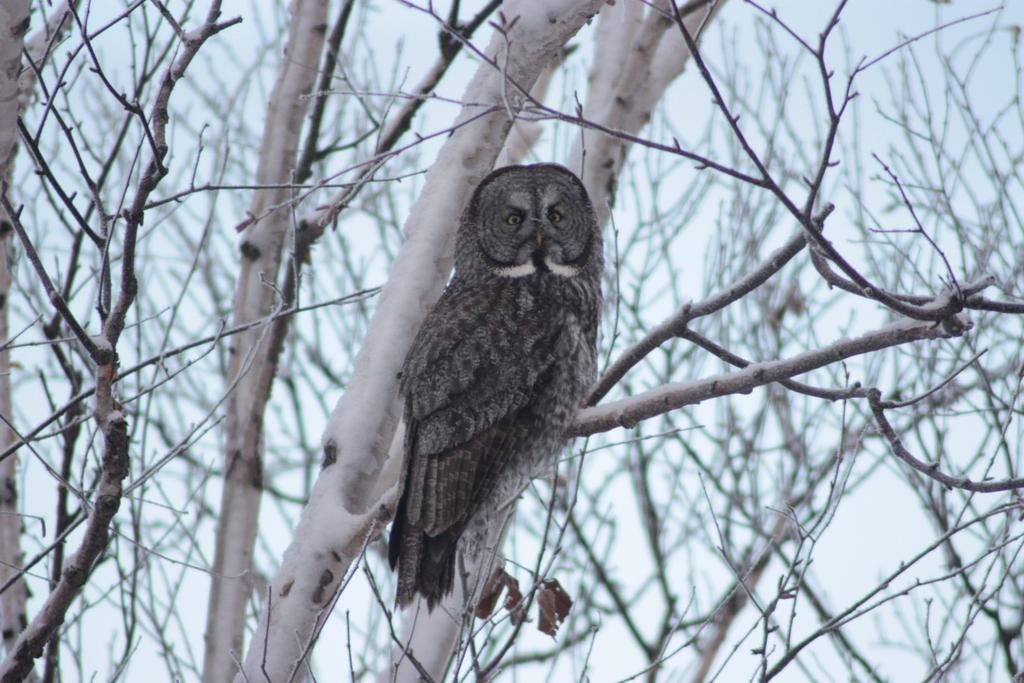What animal is the main subject of the image? There is an owl in the image. Where is the owl located in the image? The owl is on a branch of a tree. What can be seen in the background of the image? There are trees and the sky visible in the background of the image. How much profit did the farmer make from the owl in the image? There is no mention of a farmer or profit in the image, as it only features an owl on a tree branch. How many spiders are visible on the owl in the image? There are no spiders visible on the owl in the image; it is just the owl sitting on a branch. 